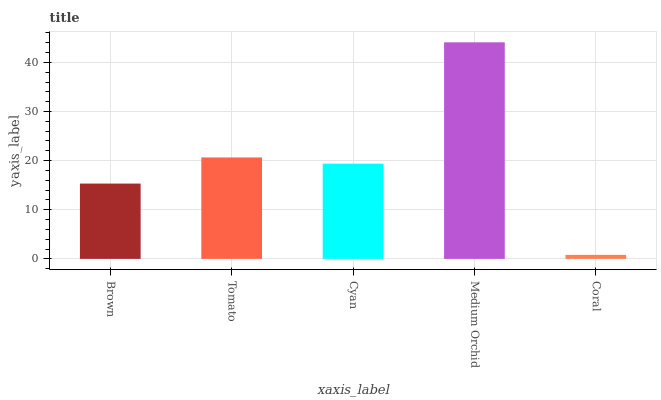Is Coral the minimum?
Answer yes or no. Yes. Is Medium Orchid the maximum?
Answer yes or no. Yes. Is Tomato the minimum?
Answer yes or no. No. Is Tomato the maximum?
Answer yes or no. No. Is Tomato greater than Brown?
Answer yes or no. Yes. Is Brown less than Tomato?
Answer yes or no. Yes. Is Brown greater than Tomato?
Answer yes or no. No. Is Tomato less than Brown?
Answer yes or no. No. Is Cyan the high median?
Answer yes or no. Yes. Is Cyan the low median?
Answer yes or no. Yes. Is Medium Orchid the high median?
Answer yes or no. No. Is Medium Orchid the low median?
Answer yes or no. No. 